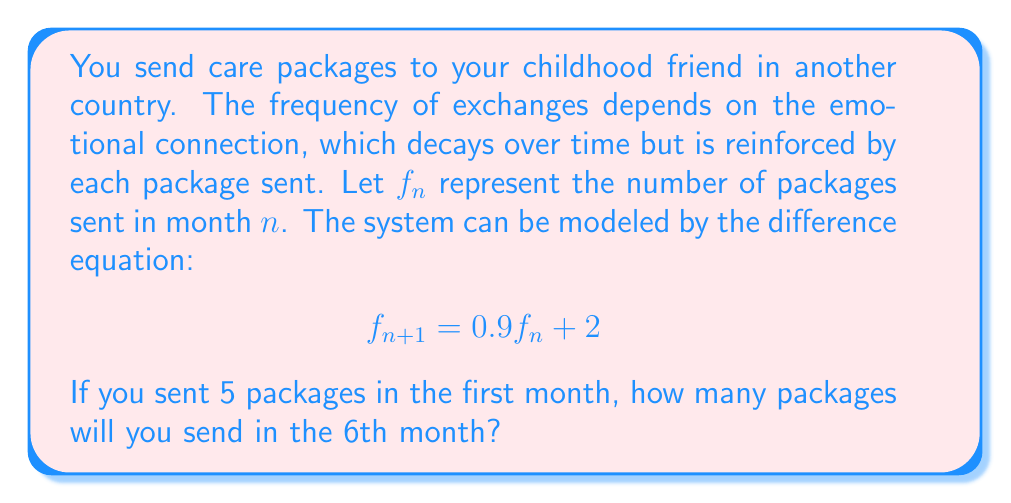Solve this math problem. To solve this problem, we need to iterate the difference equation for 5 months:

1) Initial condition: $f_1 = 5$

2) For month 2: $f_2 = 0.9f_1 + 2 = 0.9(5) + 2 = 4.5 + 2 = 6.5$

3) For month 3: $f_3 = 0.9f_2 + 2 = 0.9(6.5) + 2 = 5.85 + 2 = 7.85$

4) For month 4: $f_4 = 0.9f_3 + 2 = 0.9(7.85) + 2 = 7.065 + 2 = 9.065$

5) For month 5: $f_5 = 0.9f_4 + 2 = 0.9(9.065) + 2 = 8.1585 + 2 = 10.1585$

6) For month 6: $f_6 = 0.9f_5 + 2 = 0.9(10.1585) + 2 = 9.14265 + 2 = 11.14265$

Therefore, in the 6th month, you will send approximately 11 packages (rounding to the nearest whole number).
Answer: 11 packages 